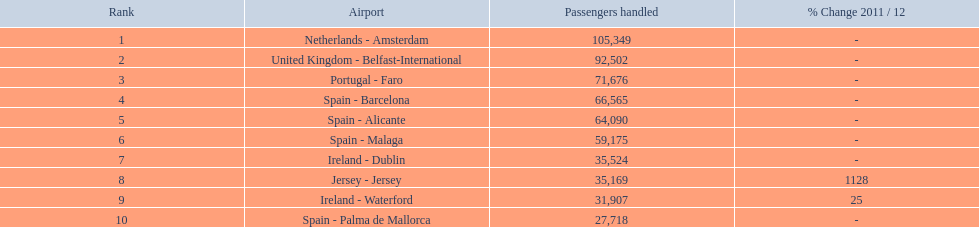What are the 10 busiest routes to and from london southend airport? Netherlands - Amsterdam, United Kingdom - Belfast-International, Portugal - Faro, Spain - Barcelona, Spain - Alicante, Spain - Malaga, Ireland - Dublin, Jersey - Jersey, Ireland - Waterford, Spain - Palma de Mallorca. Of these, which airport is in portugal? Portugal - Faro. 